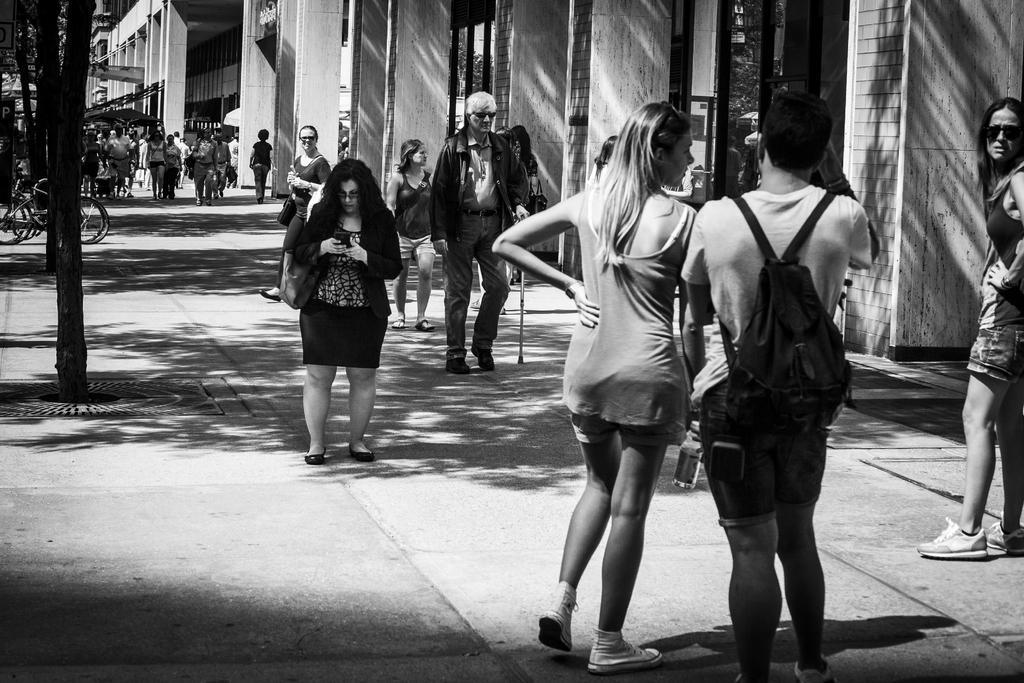Describe this image in one or two sentences. In this image we can see some buildings, some bicycles, some people are standing, some trees, some people are wearing bags, one banner, some people are holding objects and some people are walking on the road. 